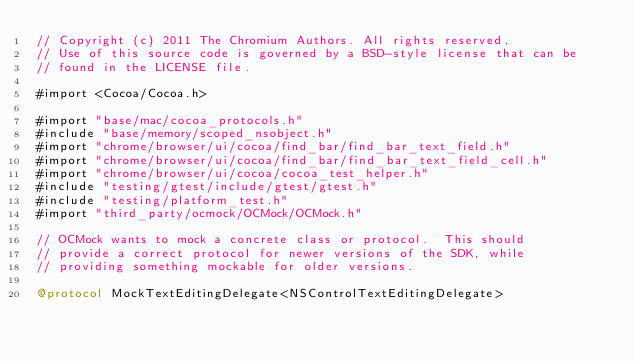Convert code to text. <code><loc_0><loc_0><loc_500><loc_500><_ObjectiveC_>// Copyright (c) 2011 The Chromium Authors. All rights reserved.
// Use of this source code is governed by a BSD-style license that can be
// found in the LICENSE file.

#import <Cocoa/Cocoa.h>

#import "base/mac/cocoa_protocols.h"
#include "base/memory/scoped_nsobject.h"
#import "chrome/browser/ui/cocoa/find_bar/find_bar_text_field.h"
#import "chrome/browser/ui/cocoa/find_bar/find_bar_text_field_cell.h"
#import "chrome/browser/ui/cocoa/cocoa_test_helper.h"
#include "testing/gtest/include/gtest/gtest.h"
#include "testing/platform_test.h"
#import "third_party/ocmock/OCMock/OCMock.h"

// OCMock wants to mock a concrete class or protocol.  This should
// provide a correct protocol for newer versions of the SDK, while
// providing something mockable for older versions.

@protocol MockTextEditingDelegate<NSControlTextEditingDelegate></code> 